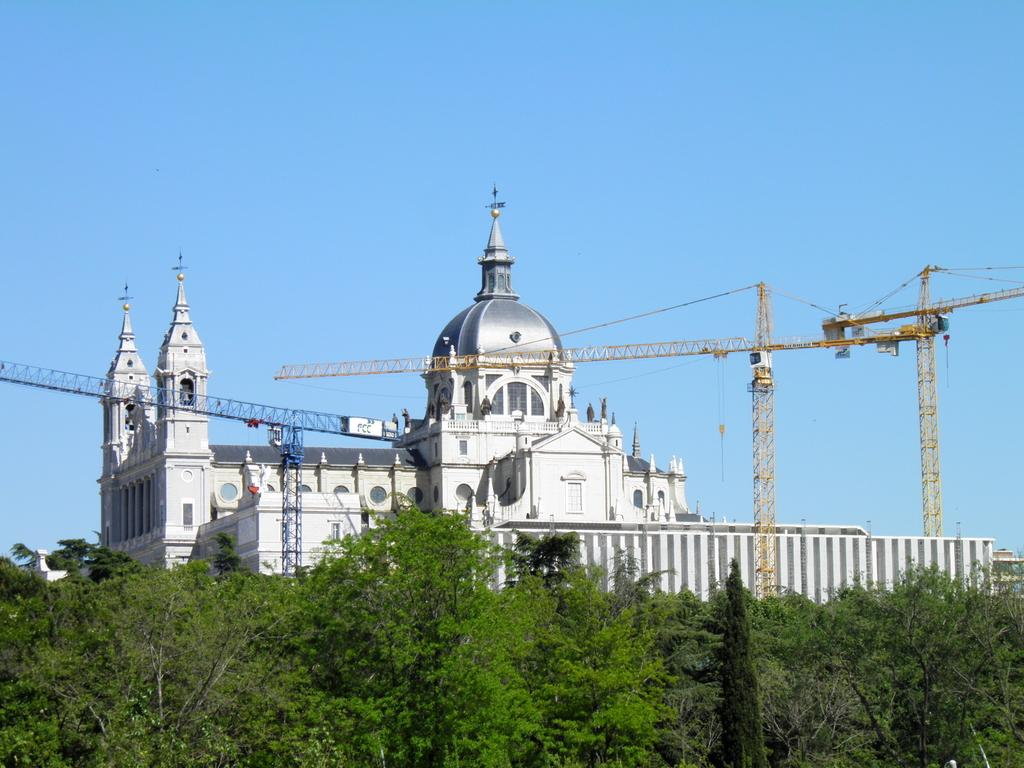What type of structures can be seen in the image? There are buildings in the image. What equipment is visible in the image that is related to construction? Construction cranes are visible in the image. What part of the natural environment is visible in the image? Trees are present in the image. What is visible in the sky in the image? The sky is visible in the image. Can you tell me how many faces are visible in the image? There are no faces present in the image; it features buildings, construction cranes, trees, and the sky. What type of memory is being stored in the image? The image does not depict any memory storage devices or processes; it is a visual representation of a scene. 